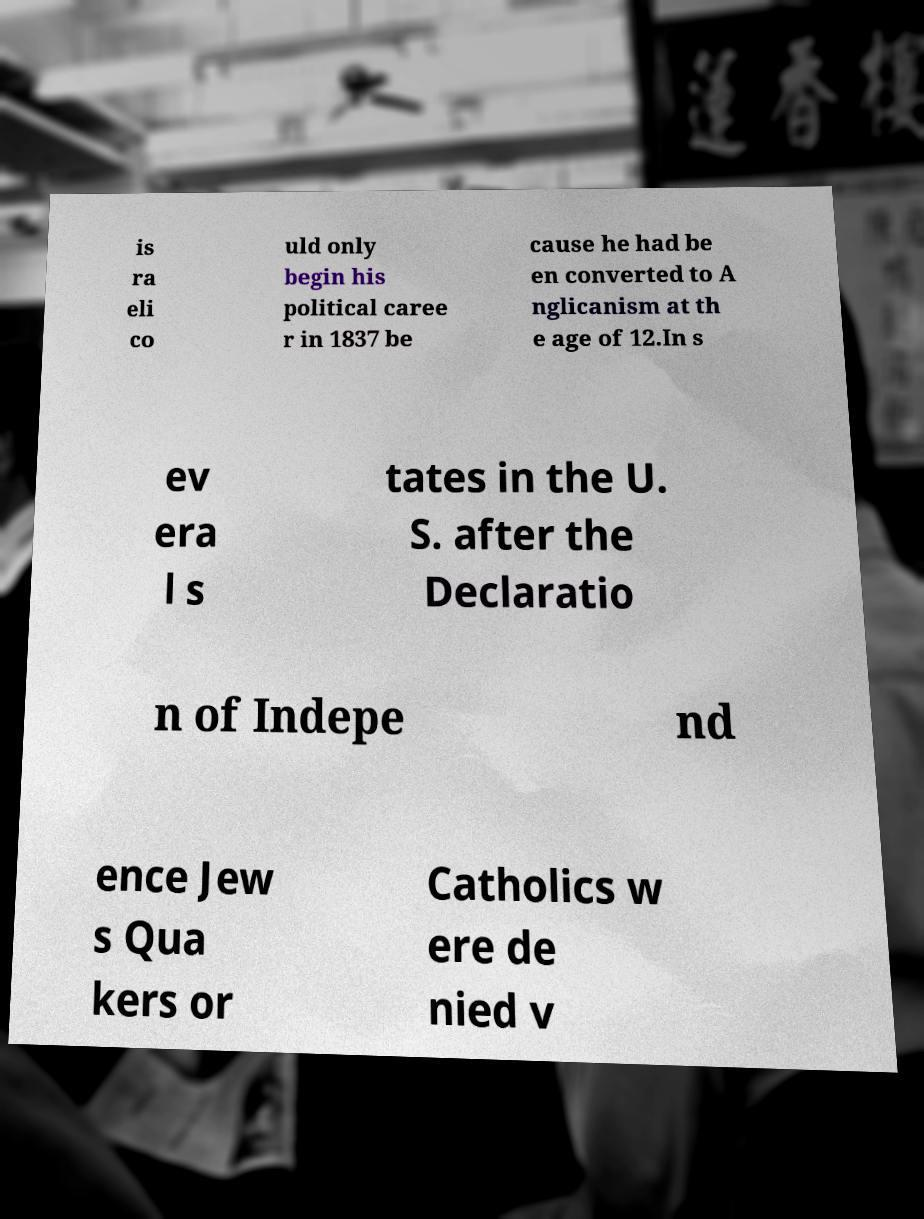For documentation purposes, I need the text within this image transcribed. Could you provide that? is ra eli co uld only begin his political caree r in 1837 be cause he had be en converted to A nglicanism at th e age of 12.In s ev era l s tates in the U. S. after the Declaratio n of Indepe nd ence Jew s Qua kers or Catholics w ere de nied v 